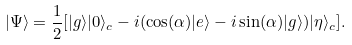Convert formula to latex. <formula><loc_0><loc_0><loc_500><loc_500>| \Psi \rangle = \frac { 1 } { 2 } [ | g \rangle | 0 \rangle _ { c } - i ( \cos ( \alpha ) | e \rangle - i \sin ( \alpha ) | g \rangle ) | \eta \rangle _ { c } ] .</formula> 